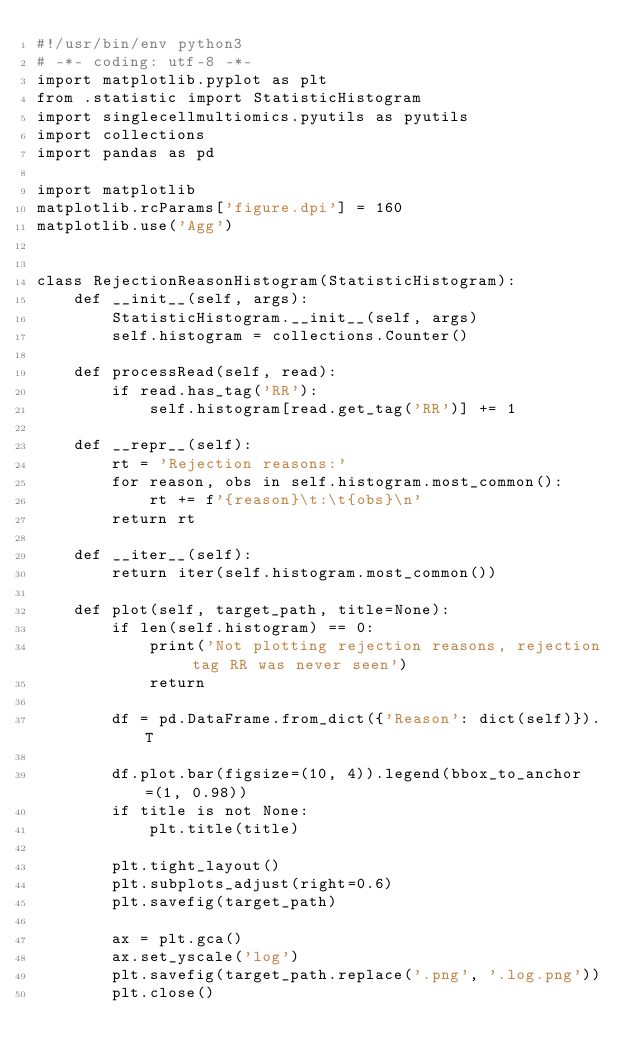<code> <loc_0><loc_0><loc_500><loc_500><_Python_>#!/usr/bin/env python3
# -*- coding: utf-8 -*-
import matplotlib.pyplot as plt
from .statistic import StatisticHistogram
import singlecellmultiomics.pyutils as pyutils
import collections
import pandas as pd

import matplotlib
matplotlib.rcParams['figure.dpi'] = 160
matplotlib.use('Agg')


class RejectionReasonHistogram(StatisticHistogram):
    def __init__(self, args):
        StatisticHistogram.__init__(self, args)
        self.histogram = collections.Counter()

    def processRead(self, read):
        if read.has_tag('RR'):
            self.histogram[read.get_tag('RR')] += 1

    def __repr__(self):
        rt = 'Rejection reasons:'
        for reason, obs in self.histogram.most_common():
            rt += f'{reason}\t:\t{obs}\n'
        return rt

    def __iter__(self):
        return iter(self.histogram.most_common())

    def plot(self, target_path, title=None):
        if len(self.histogram) == 0:
            print('Not plotting rejection reasons, rejection tag RR was never seen')
            return

        df = pd.DataFrame.from_dict({'Reason': dict(self)}).T

        df.plot.bar(figsize=(10, 4)).legend(bbox_to_anchor=(1, 0.98))
        if title is not None:
            plt.title(title)

        plt.tight_layout()
        plt.subplots_adjust(right=0.6)
        plt.savefig(target_path)

        ax = plt.gca()
        ax.set_yscale('log')
        plt.savefig(target_path.replace('.png', '.log.png'))
        plt.close()
</code> 